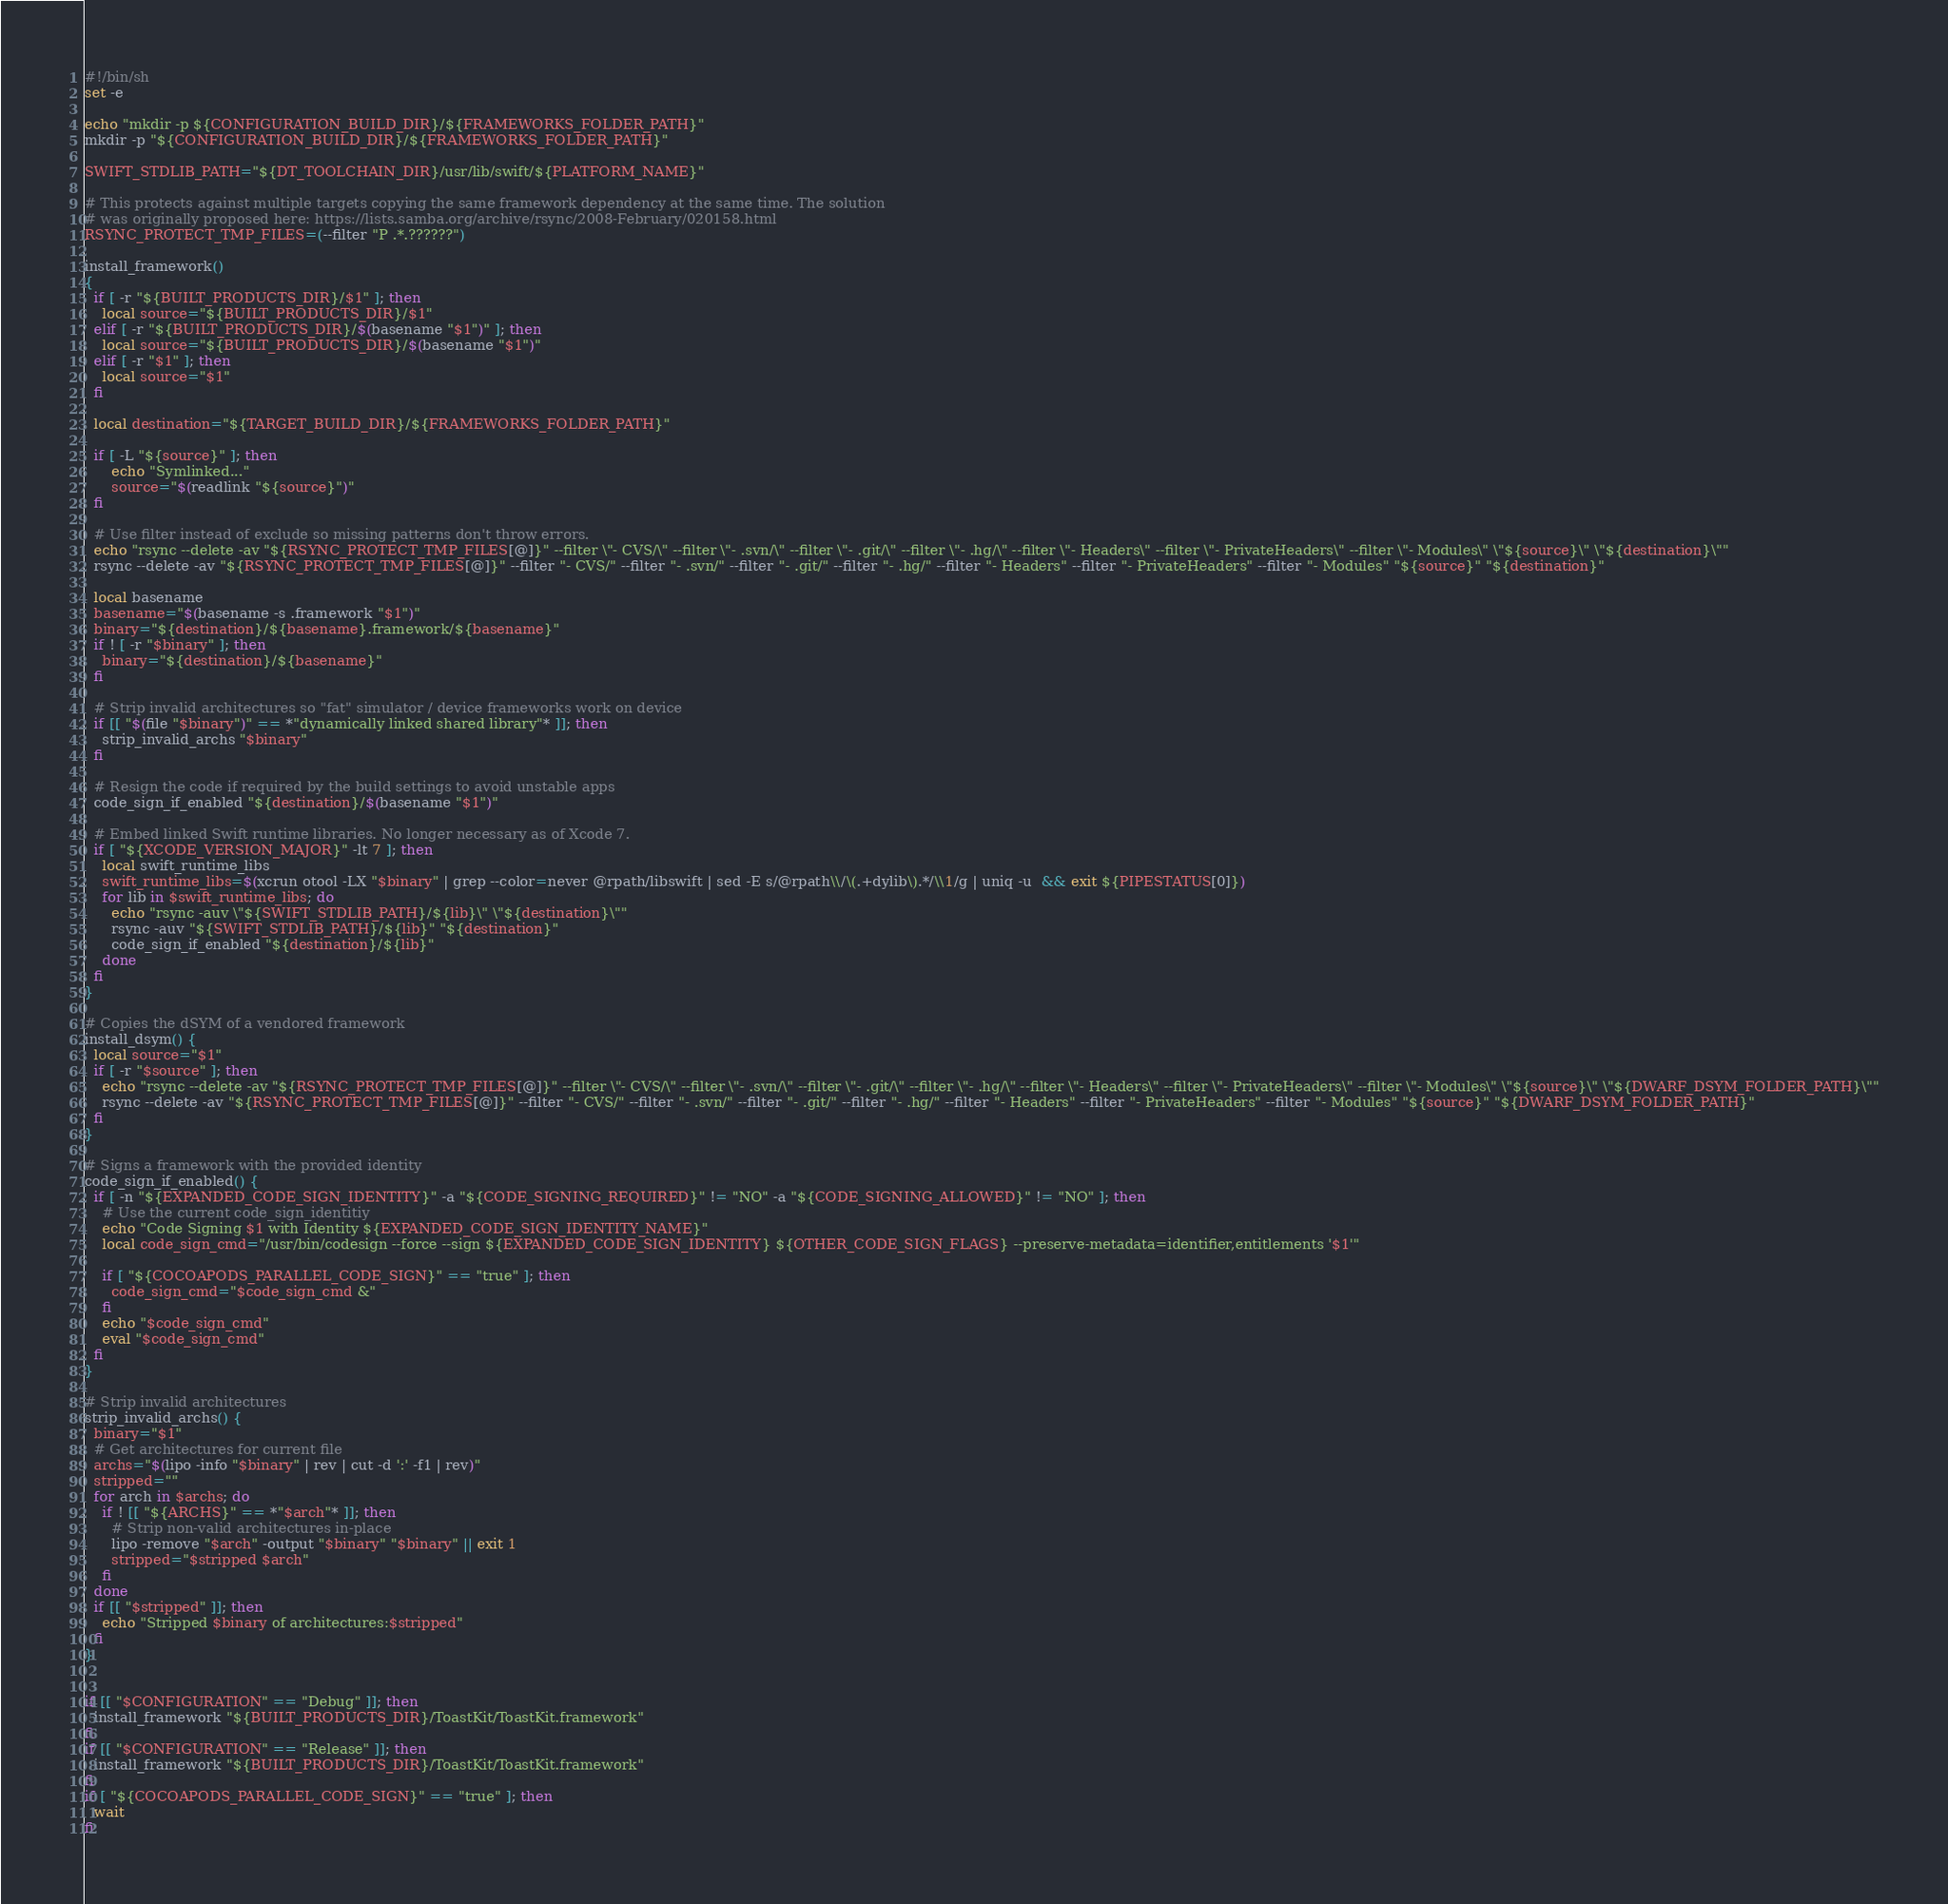Convert code to text. <code><loc_0><loc_0><loc_500><loc_500><_Bash_>#!/bin/sh
set -e

echo "mkdir -p ${CONFIGURATION_BUILD_DIR}/${FRAMEWORKS_FOLDER_PATH}"
mkdir -p "${CONFIGURATION_BUILD_DIR}/${FRAMEWORKS_FOLDER_PATH}"

SWIFT_STDLIB_PATH="${DT_TOOLCHAIN_DIR}/usr/lib/swift/${PLATFORM_NAME}"

# This protects against multiple targets copying the same framework dependency at the same time. The solution
# was originally proposed here: https://lists.samba.org/archive/rsync/2008-February/020158.html
RSYNC_PROTECT_TMP_FILES=(--filter "P .*.??????")

install_framework()
{
  if [ -r "${BUILT_PRODUCTS_DIR}/$1" ]; then
    local source="${BUILT_PRODUCTS_DIR}/$1"
  elif [ -r "${BUILT_PRODUCTS_DIR}/$(basename "$1")" ]; then
    local source="${BUILT_PRODUCTS_DIR}/$(basename "$1")"
  elif [ -r "$1" ]; then
    local source="$1"
  fi

  local destination="${TARGET_BUILD_DIR}/${FRAMEWORKS_FOLDER_PATH}"

  if [ -L "${source}" ]; then
      echo "Symlinked..."
      source="$(readlink "${source}")"
  fi

  # Use filter instead of exclude so missing patterns don't throw errors.
  echo "rsync --delete -av "${RSYNC_PROTECT_TMP_FILES[@]}" --filter \"- CVS/\" --filter \"- .svn/\" --filter \"- .git/\" --filter \"- .hg/\" --filter \"- Headers\" --filter \"- PrivateHeaders\" --filter \"- Modules\" \"${source}\" \"${destination}\""
  rsync --delete -av "${RSYNC_PROTECT_TMP_FILES[@]}" --filter "- CVS/" --filter "- .svn/" --filter "- .git/" --filter "- .hg/" --filter "- Headers" --filter "- PrivateHeaders" --filter "- Modules" "${source}" "${destination}"

  local basename
  basename="$(basename -s .framework "$1")"
  binary="${destination}/${basename}.framework/${basename}"
  if ! [ -r "$binary" ]; then
    binary="${destination}/${basename}"
  fi

  # Strip invalid architectures so "fat" simulator / device frameworks work on device
  if [[ "$(file "$binary")" == *"dynamically linked shared library"* ]]; then
    strip_invalid_archs "$binary"
  fi

  # Resign the code if required by the build settings to avoid unstable apps
  code_sign_if_enabled "${destination}/$(basename "$1")"

  # Embed linked Swift runtime libraries. No longer necessary as of Xcode 7.
  if [ "${XCODE_VERSION_MAJOR}" -lt 7 ]; then
    local swift_runtime_libs
    swift_runtime_libs=$(xcrun otool -LX "$binary" | grep --color=never @rpath/libswift | sed -E s/@rpath\\/\(.+dylib\).*/\\1/g | uniq -u  && exit ${PIPESTATUS[0]})
    for lib in $swift_runtime_libs; do
      echo "rsync -auv \"${SWIFT_STDLIB_PATH}/${lib}\" \"${destination}\""
      rsync -auv "${SWIFT_STDLIB_PATH}/${lib}" "${destination}"
      code_sign_if_enabled "${destination}/${lib}"
    done
  fi
}

# Copies the dSYM of a vendored framework
install_dsym() {
  local source="$1"
  if [ -r "$source" ]; then
    echo "rsync --delete -av "${RSYNC_PROTECT_TMP_FILES[@]}" --filter \"- CVS/\" --filter \"- .svn/\" --filter \"- .git/\" --filter \"- .hg/\" --filter \"- Headers\" --filter \"- PrivateHeaders\" --filter \"- Modules\" \"${source}\" \"${DWARF_DSYM_FOLDER_PATH}\""
    rsync --delete -av "${RSYNC_PROTECT_TMP_FILES[@]}" --filter "- CVS/" --filter "- .svn/" --filter "- .git/" --filter "- .hg/" --filter "- Headers" --filter "- PrivateHeaders" --filter "- Modules" "${source}" "${DWARF_DSYM_FOLDER_PATH}"
  fi
}

# Signs a framework with the provided identity
code_sign_if_enabled() {
  if [ -n "${EXPANDED_CODE_SIGN_IDENTITY}" -a "${CODE_SIGNING_REQUIRED}" != "NO" -a "${CODE_SIGNING_ALLOWED}" != "NO" ]; then
    # Use the current code_sign_identitiy
    echo "Code Signing $1 with Identity ${EXPANDED_CODE_SIGN_IDENTITY_NAME}"
    local code_sign_cmd="/usr/bin/codesign --force --sign ${EXPANDED_CODE_SIGN_IDENTITY} ${OTHER_CODE_SIGN_FLAGS} --preserve-metadata=identifier,entitlements '$1'"

    if [ "${COCOAPODS_PARALLEL_CODE_SIGN}" == "true" ]; then
      code_sign_cmd="$code_sign_cmd &"
    fi
    echo "$code_sign_cmd"
    eval "$code_sign_cmd"
  fi
}

# Strip invalid architectures
strip_invalid_archs() {
  binary="$1"
  # Get architectures for current file
  archs="$(lipo -info "$binary" | rev | cut -d ':' -f1 | rev)"
  stripped=""
  for arch in $archs; do
    if ! [[ "${ARCHS}" == *"$arch"* ]]; then
      # Strip non-valid architectures in-place
      lipo -remove "$arch" -output "$binary" "$binary" || exit 1
      stripped="$stripped $arch"
    fi
  done
  if [[ "$stripped" ]]; then
    echo "Stripped $binary of architectures:$stripped"
  fi
}


if [[ "$CONFIGURATION" == "Debug" ]]; then
  install_framework "${BUILT_PRODUCTS_DIR}/ToastKit/ToastKit.framework"
fi
if [[ "$CONFIGURATION" == "Release" ]]; then
  install_framework "${BUILT_PRODUCTS_DIR}/ToastKit/ToastKit.framework"
fi
if [ "${COCOAPODS_PARALLEL_CODE_SIGN}" == "true" ]; then
  wait
fi
</code> 